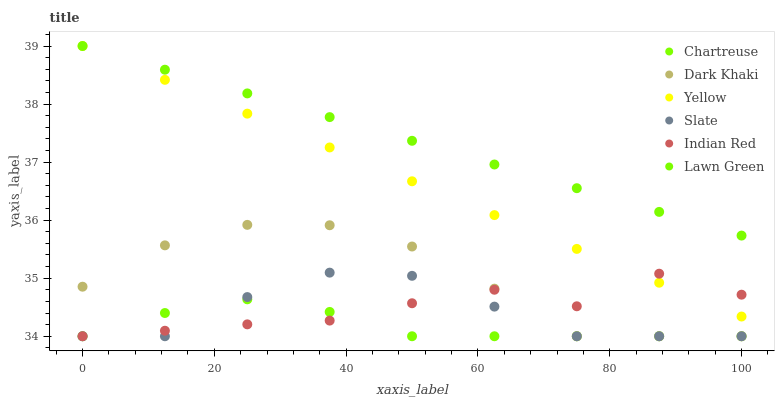Does Chartreuse have the minimum area under the curve?
Answer yes or no. Yes. Does Lawn Green have the maximum area under the curve?
Answer yes or no. Yes. Does Slate have the minimum area under the curve?
Answer yes or no. No. Does Slate have the maximum area under the curve?
Answer yes or no. No. Is Yellow the smoothest?
Answer yes or no. Yes. Is Indian Red the roughest?
Answer yes or no. Yes. Is Slate the smoothest?
Answer yes or no. No. Is Slate the roughest?
Answer yes or no. No. Does Slate have the lowest value?
Answer yes or no. Yes. Does Yellow have the lowest value?
Answer yes or no. No. Does Yellow have the highest value?
Answer yes or no. Yes. Does Slate have the highest value?
Answer yes or no. No. Is Indian Red less than Lawn Green?
Answer yes or no. Yes. Is Yellow greater than Slate?
Answer yes or no. Yes. Does Slate intersect Chartreuse?
Answer yes or no. Yes. Is Slate less than Chartreuse?
Answer yes or no. No. Is Slate greater than Chartreuse?
Answer yes or no. No. Does Indian Red intersect Lawn Green?
Answer yes or no. No. 